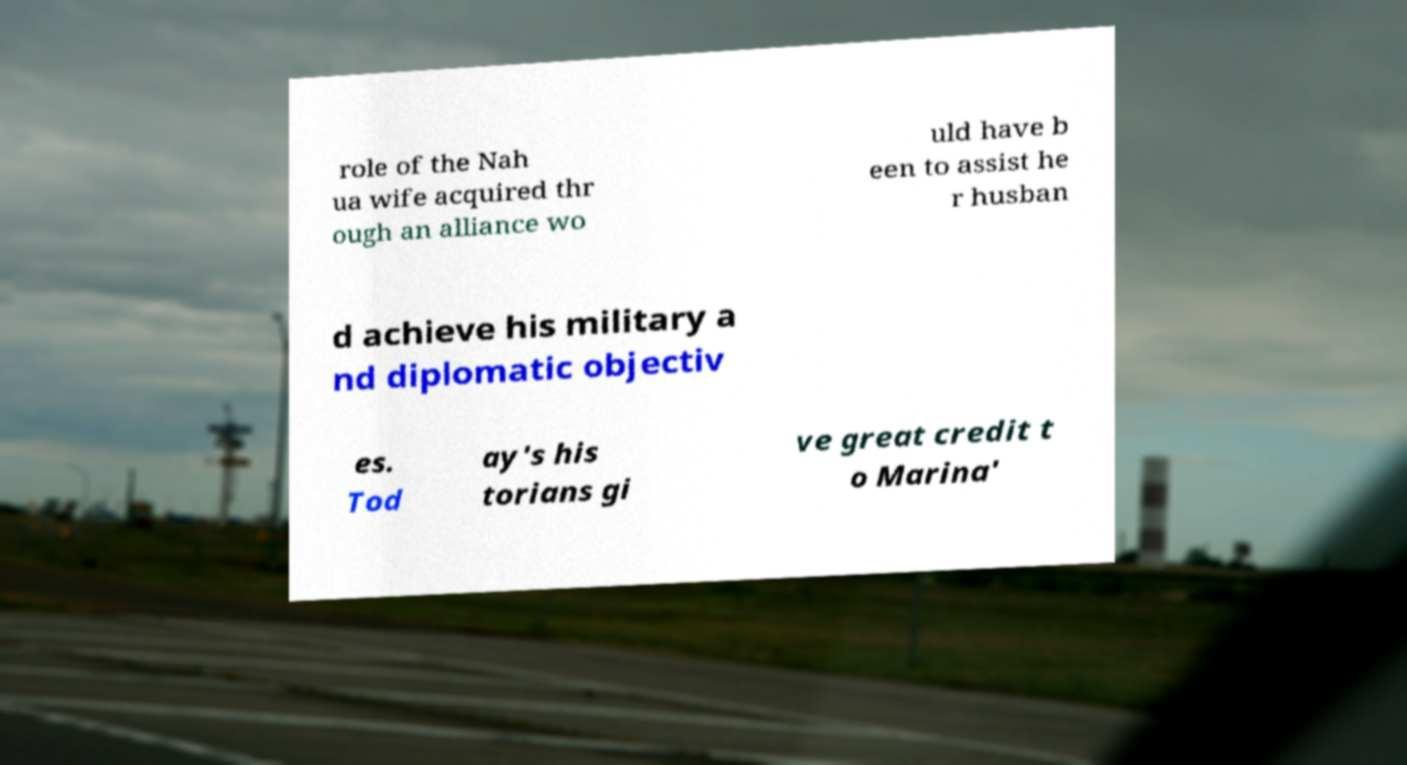Can you read and provide the text displayed in the image?This photo seems to have some interesting text. Can you extract and type it out for me? role of the Nah ua wife acquired thr ough an alliance wo uld have b een to assist he r husban d achieve his military a nd diplomatic objectiv es. Tod ay's his torians gi ve great credit t o Marina' 